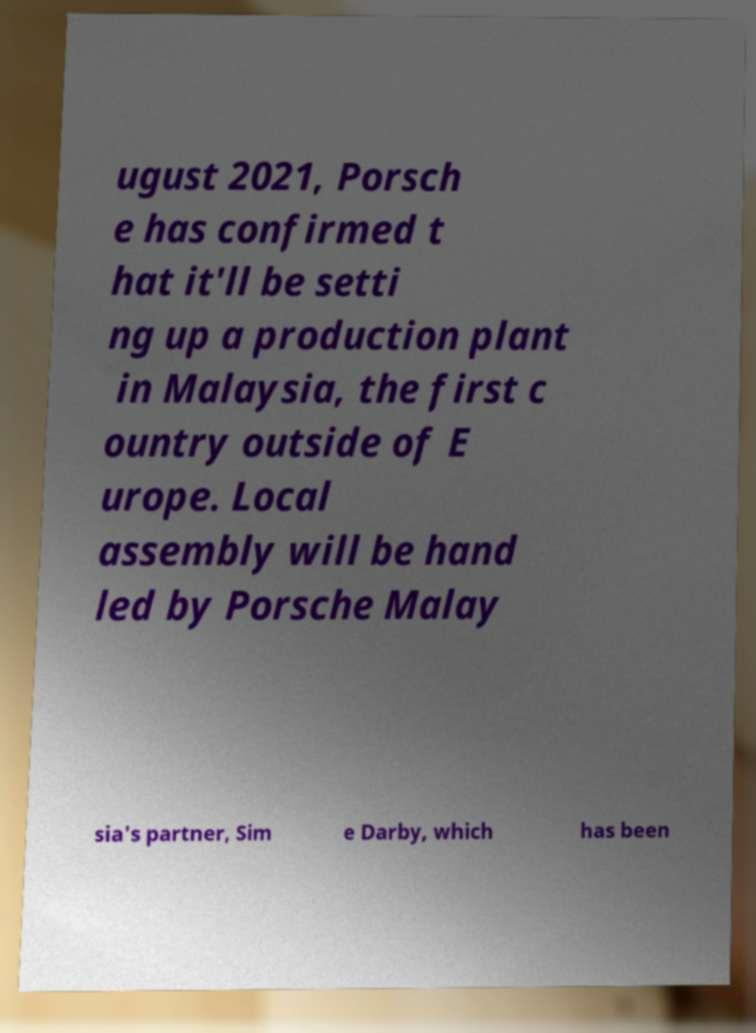Can you accurately transcribe the text from the provided image for me? ugust 2021, Porsch e has confirmed t hat it'll be setti ng up a production plant in Malaysia, the first c ountry outside of E urope. Local assembly will be hand led by Porsche Malay sia's partner, Sim e Darby, which has been 